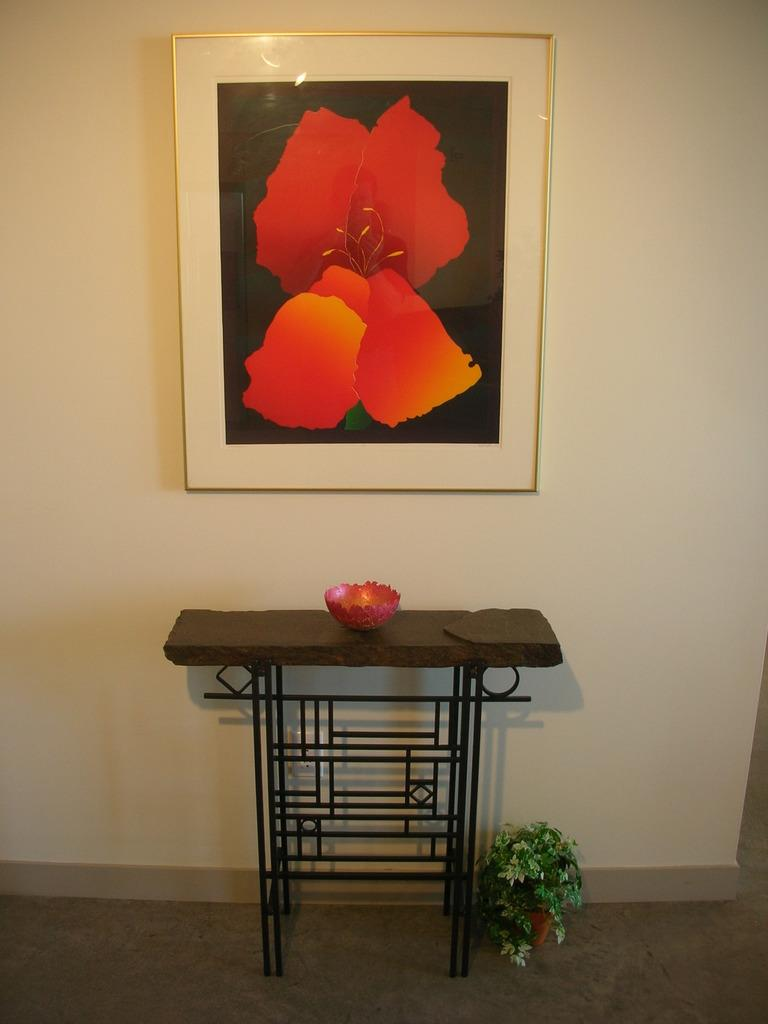What piece of furniture is present in the image? There is a table in the image. What is on top of the table? The table has a bowl on it. What type of plant can be seen in the image? There is a pot with a plant in the image. Where is the pot with the plant located in relation to the table? The pot is beside the table. What is hanging on the wall in the image? There is a picture frame attached to the wall in the image. What type of quartz is used to make the joke in the image? There is no quartz or joke present in the image. 